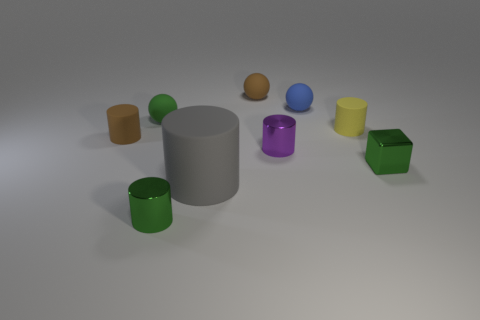Are there any objects that seem out of place or different from the others? In this composition, while most objects share similar geometrical shapes, the cylindrical gray object stands out due to its size and shape, which contrasts with the other smaller, more colorful objects. What might be the function of these objects if they were real? If these were real objects, they might serve various functions: the containers could be used for storage, and the cylindrical object might serve as a vase or a holder for other items. 